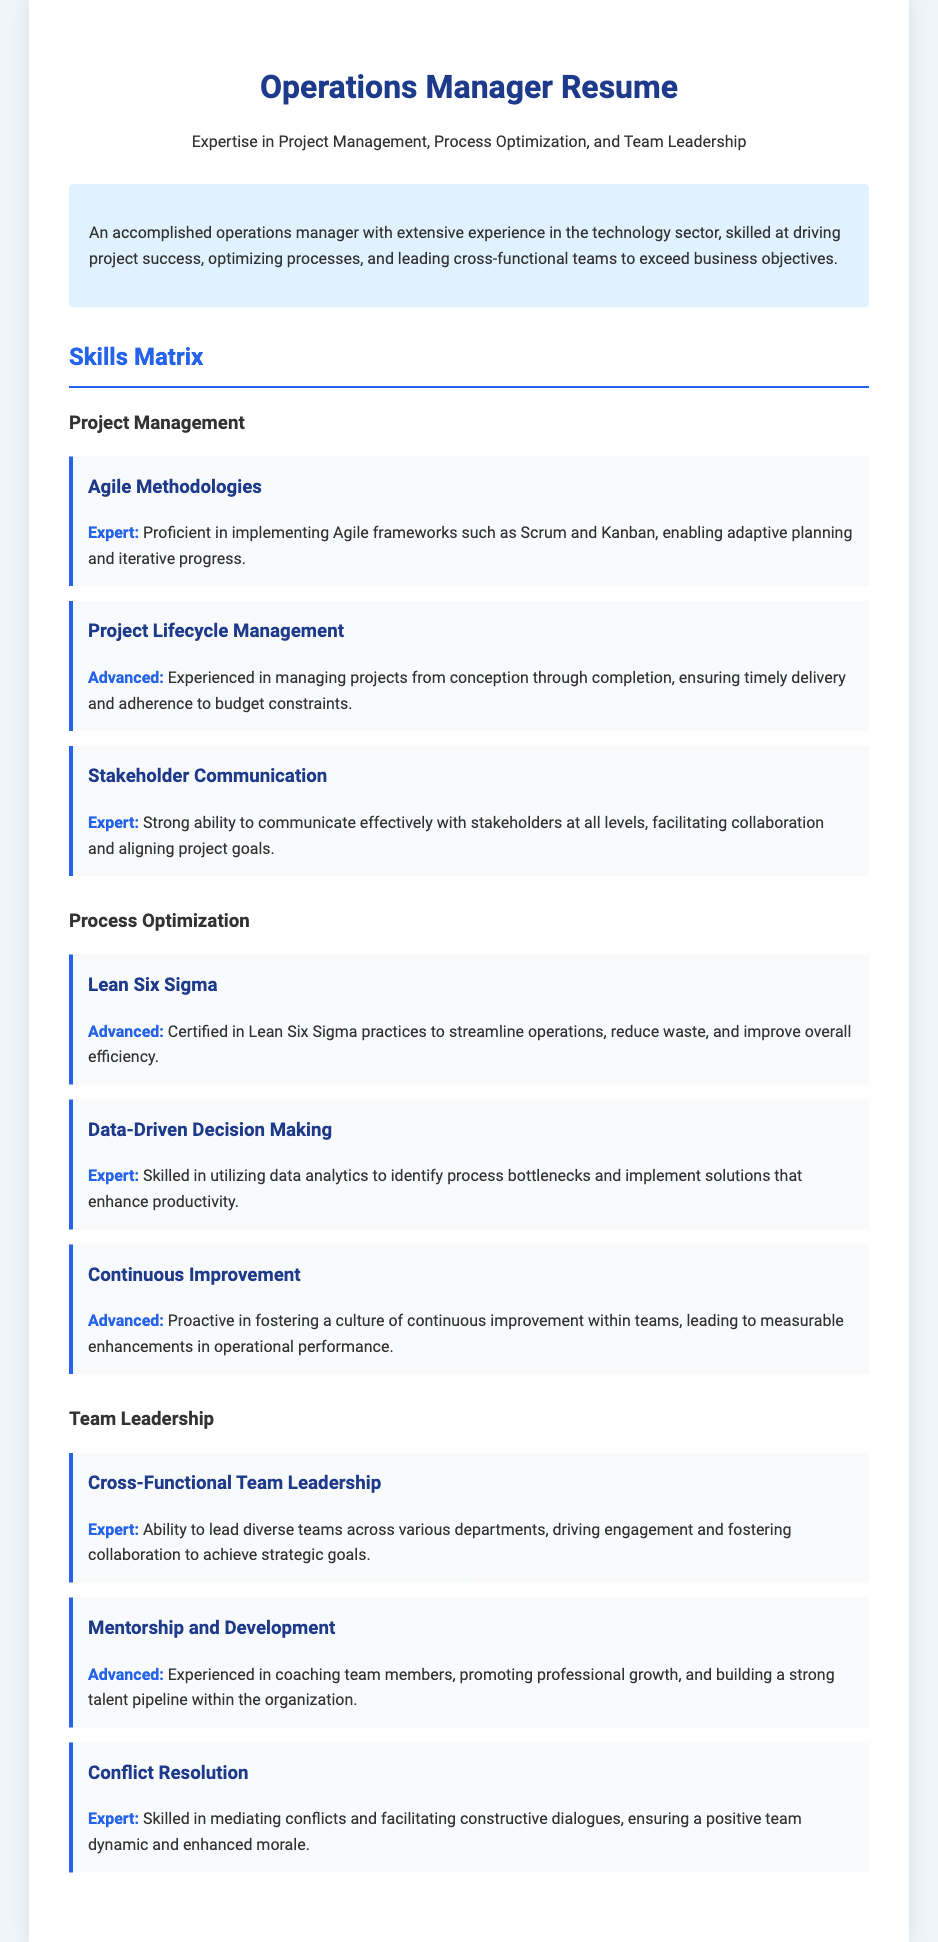what is the title of the document? The title of the document is featured prominently at the top of the resume, indicating the job role.
Answer: Operations Manager Resume how many skills are listed under Project Management? By counting the skills listed in the Project Management category, we find that there are three skills.
Answer: 3 what certification does the applicant hold in Process Optimization? The applicant mentions a certification that is related to process improvement.
Answer: Lean Six Sigma what is the main focus of the summary section? The summary section provides a brief overview of the applicant's professional strengths and experiences.
Answer: Driving project success which framework is mentioned related to Agile Methodologies? Within the Agile Methodologies skill, specific frameworks are referenced as part of the competencies.
Answer: Scrum and Kanban how would you describe the applicant's ability to lead teams? This question asks for a qualitative assessment based on the listed skills in the Team Leadership category.
Answer: Expert what is the skill level for Data-Driven Decision Making? The skill level for Data-Driven Decision Making is indicated clearly in the document.
Answer: Expert which category includes Conflict Resolution? This category refers to the set of skills related to leading and managing teams effectively.
Answer: Team Leadership 